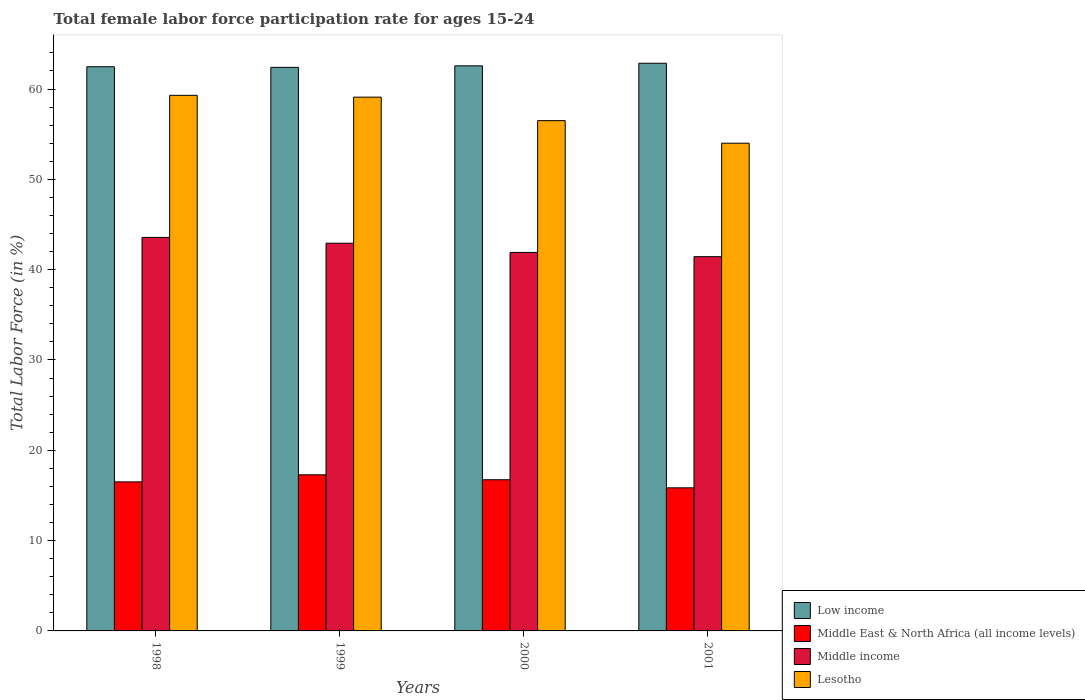How many different coloured bars are there?
Ensure brevity in your answer.  4. How many groups of bars are there?
Offer a very short reply. 4. Are the number of bars per tick equal to the number of legend labels?
Offer a terse response. Yes. Are the number of bars on each tick of the X-axis equal?
Ensure brevity in your answer.  Yes. What is the label of the 1st group of bars from the left?
Give a very brief answer. 1998. What is the female labor force participation rate in Middle income in 2001?
Provide a succinct answer. 41.44. Across all years, what is the maximum female labor force participation rate in Lesotho?
Ensure brevity in your answer.  59.3. Across all years, what is the minimum female labor force participation rate in Lesotho?
Ensure brevity in your answer.  54. In which year was the female labor force participation rate in Lesotho maximum?
Offer a very short reply. 1998. In which year was the female labor force participation rate in Middle income minimum?
Make the answer very short. 2001. What is the total female labor force participation rate in Middle East & North Africa (all income levels) in the graph?
Your answer should be compact. 66.37. What is the difference between the female labor force participation rate in Low income in 1999 and that in 2000?
Offer a very short reply. -0.17. What is the difference between the female labor force participation rate in Middle income in 2000 and the female labor force participation rate in Middle East & North Africa (all income levels) in 1999?
Keep it short and to the point. 24.62. What is the average female labor force participation rate in Middle income per year?
Offer a terse response. 42.46. In the year 1998, what is the difference between the female labor force participation rate in Lesotho and female labor force participation rate in Middle income?
Ensure brevity in your answer.  15.73. In how many years, is the female labor force participation rate in Middle East & North Africa (all income levels) greater than 18 %?
Your response must be concise. 0. What is the ratio of the female labor force participation rate in Lesotho in 1998 to that in 2000?
Keep it short and to the point. 1.05. Is the difference between the female labor force participation rate in Lesotho in 1998 and 1999 greater than the difference between the female labor force participation rate in Middle income in 1998 and 1999?
Offer a very short reply. No. What is the difference between the highest and the second highest female labor force participation rate in Middle East & North Africa (all income levels)?
Keep it short and to the point. 0.55. What is the difference between the highest and the lowest female labor force participation rate in Middle East & North Africa (all income levels)?
Offer a very short reply. 1.44. In how many years, is the female labor force participation rate in Lesotho greater than the average female labor force participation rate in Lesotho taken over all years?
Offer a very short reply. 2. Is the sum of the female labor force participation rate in Middle East & North Africa (all income levels) in 1998 and 2000 greater than the maximum female labor force participation rate in Lesotho across all years?
Your response must be concise. No. Is it the case that in every year, the sum of the female labor force participation rate in Lesotho and female labor force participation rate in Middle East & North Africa (all income levels) is greater than the sum of female labor force participation rate in Middle income and female labor force participation rate in Low income?
Your response must be concise. No. What does the 1st bar from the right in 1999 represents?
Your answer should be compact. Lesotho. Are all the bars in the graph horizontal?
Offer a terse response. No. What is the difference between two consecutive major ticks on the Y-axis?
Your answer should be compact. 10. Are the values on the major ticks of Y-axis written in scientific E-notation?
Your answer should be compact. No. How many legend labels are there?
Your answer should be compact. 4. What is the title of the graph?
Offer a terse response. Total female labor force participation rate for ages 15-24. What is the label or title of the Y-axis?
Keep it short and to the point. Total Labor Force (in %). What is the Total Labor Force (in %) of Low income in 1998?
Give a very brief answer. 62.47. What is the Total Labor Force (in %) of Middle East & North Africa (all income levels) in 1998?
Make the answer very short. 16.5. What is the Total Labor Force (in %) of Middle income in 1998?
Keep it short and to the point. 43.57. What is the Total Labor Force (in %) of Lesotho in 1998?
Offer a very short reply. 59.3. What is the Total Labor Force (in %) of Low income in 1999?
Give a very brief answer. 62.4. What is the Total Labor Force (in %) of Middle East & North Africa (all income levels) in 1999?
Your answer should be very brief. 17.28. What is the Total Labor Force (in %) of Middle income in 1999?
Ensure brevity in your answer.  42.93. What is the Total Labor Force (in %) of Lesotho in 1999?
Offer a very short reply. 59.1. What is the Total Labor Force (in %) in Low income in 2000?
Keep it short and to the point. 62.57. What is the Total Labor Force (in %) in Middle East & North Africa (all income levels) in 2000?
Give a very brief answer. 16.74. What is the Total Labor Force (in %) in Middle income in 2000?
Provide a succinct answer. 41.91. What is the Total Labor Force (in %) of Lesotho in 2000?
Provide a short and direct response. 56.5. What is the Total Labor Force (in %) of Low income in 2001?
Your answer should be very brief. 62.85. What is the Total Labor Force (in %) in Middle East & North Africa (all income levels) in 2001?
Your answer should be compact. 15.84. What is the Total Labor Force (in %) of Middle income in 2001?
Keep it short and to the point. 41.44. What is the Total Labor Force (in %) of Lesotho in 2001?
Ensure brevity in your answer.  54. Across all years, what is the maximum Total Labor Force (in %) in Low income?
Provide a succinct answer. 62.85. Across all years, what is the maximum Total Labor Force (in %) in Middle East & North Africa (all income levels)?
Your answer should be compact. 17.28. Across all years, what is the maximum Total Labor Force (in %) in Middle income?
Your response must be concise. 43.57. Across all years, what is the maximum Total Labor Force (in %) in Lesotho?
Your answer should be compact. 59.3. Across all years, what is the minimum Total Labor Force (in %) of Low income?
Your answer should be very brief. 62.4. Across all years, what is the minimum Total Labor Force (in %) in Middle East & North Africa (all income levels)?
Provide a succinct answer. 15.84. Across all years, what is the minimum Total Labor Force (in %) of Middle income?
Keep it short and to the point. 41.44. What is the total Total Labor Force (in %) of Low income in the graph?
Your answer should be very brief. 250.28. What is the total Total Labor Force (in %) of Middle East & North Africa (all income levels) in the graph?
Make the answer very short. 66.37. What is the total Total Labor Force (in %) of Middle income in the graph?
Ensure brevity in your answer.  169.84. What is the total Total Labor Force (in %) of Lesotho in the graph?
Your answer should be very brief. 228.9. What is the difference between the Total Labor Force (in %) in Low income in 1998 and that in 1999?
Make the answer very short. 0.07. What is the difference between the Total Labor Force (in %) of Middle East & North Africa (all income levels) in 1998 and that in 1999?
Keep it short and to the point. -0.78. What is the difference between the Total Labor Force (in %) in Middle income in 1998 and that in 1999?
Keep it short and to the point. 0.64. What is the difference between the Total Labor Force (in %) of Low income in 1998 and that in 2000?
Provide a short and direct response. -0.1. What is the difference between the Total Labor Force (in %) of Middle East & North Africa (all income levels) in 1998 and that in 2000?
Give a very brief answer. -0.24. What is the difference between the Total Labor Force (in %) in Middle income in 1998 and that in 2000?
Provide a short and direct response. 1.66. What is the difference between the Total Labor Force (in %) of Low income in 1998 and that in 2001?
Provide a short and direct response. -0.38. What is the difference between the Total Labor Force (in %) of Middle East & North Africa (all income levels) in 1998 and that in 2001?
Make the answer very short. 0.66. What is the difference between the Total Labor Force (in %) of Middle income in 1998 and that in 2001?
Provide a short and direct response. 2.13. What is the difference between the Total Labor Force (in %) in Low income in 1999 and that in 2000?
Your answer should be compact. -0.17. What is the difference between the Total Labor Force (in %) of Middle East & North Africa (all income levels) in 1999 and that in 2000?
Give a very brief answer. 0.55. What is the difference between the Total Labor Force (in %) in Middle income in 1999 and that in 2000?
Ensure brevity in your answer.  1.02. What is the difference between the Total Labor Force (in %) of Low income in 1999 and that in 2001?
Offer a terse response. -0.46. What is the difference between the Total Labor Force (in %) of Middle East & North Africa (all income levels) in 1999 and that in 2001?
Ensure brevity in your answer.  1.44. What is the difference between the Total Labor Force (in %) in Middle income in 1999 and that in 2001?
Offer a terse response. 1.49. What is the difference between the Total Labor Force (in %) in Lesotho in 1999 and that in 2001?
Make the answer very short. 5.1. What is the difference between the Total Labor Force (in %) in Low income in 2000 and that in 2001?
Make the answer very short. -0.29. What is the difference between the Total Labor Force (in %) in Middle East & North Africa (all income levels) in 2000 and that in 2001?
Keep it short and to the point. 0.9. What is the difference between the Total Labor Force (in %) in Middle income in 2000 and that in 2001?
Keep it short and to the point. 0.47. What is the difference between the Total Labor Force (in %) of Low income in 1998 and the Total Labor Force (in %) of Middle East & North Africa (all income levels) in 1999?
Ensure brevity in your answer.  45.18. What is the difference between the Total Labor Force (in %) of Low income in 1998 and the Total Labor Force (in %) of Middle income in 1999?
Your answer should be compact. 19.54. What is the difference between the Total Labor Force (in %) of Low income in 1998 and the Total Labor Force (in %) of Lesotho in 1999?
Offer a very short reply. 3.37. What is the difference between the Total Labor Force (in %) of Middle East & North Africa (all income levels) in 1998 and the Total Labor Force (in %) of Middle income in 1999?
Your response must be concise. -26.43. What is the difference between the Total Labor Force (in %) of Middle East & North Africa (all income levels) in 1998 and the Total Labor Force (in %) of Lesotho in 1999?
Ensure brevity in your answer.  -42.6. What is the difference between the Total Labor Force (in %) of Middle income in 1998 and the Total Labor Force (in %) of Lesotho in 1999?
Provide a succinct answer. -15.53. What is the difference between the Total Labor Force (in %) of Low income in 1998 and the Total Labor Force (in %) of Middle East & North Africa (all income levels) in 2000?
Offer a very short reply. 45.73. What is the difference between the Total Labor Force (in %) in Low income in 1998 and the Total Labor Force (in %) in Middle income in 2000?
Your answer should be very brief. 20.56. What is the difference between the Total Labor Force (in %) of Low income in 1998 and the Total Labor Force (in %) of Lesotho in 2000?
Provide a short and direct response. 5.97. What is the difference between the Total Labor Force (in %) of Middle East & North Africa (all income levels) in 1998 and the Total Labor Force (in %) of Middle income in 2000?
Your answer should be very brief. -25.41. What is the difference between the Total Labor Force (in %) in Middle East & North Africa (all income levels) in 1998 and the Total Labor Force (in %) in Lesotho in 2000?
Your answer should be compact. -40. What is the difference between the Total Labor Force (in %) in Middle income in 1998 and the Total Labor Force (in %) in Lesotho in 2000?
Keep it short and to the point. -12.93. What is the difference between the Total Labor Force (in %) in Low income in 1998 and the Total Labor Force (in %) in Middle East & North Africa (all income levels) in 2001?
Keep it short and to the point. 46.63. What is the difference between the Total Labor Force (in %) in Low income in 1998 and the Total Labor Force (in %) in Middle income in 2001?
Your answer should be very brief. 21.03. What is the difference between the Total Labor Force (in %) in Low income in 1998 and the Total Labor Force (in %) in Lesotho in 2001?
Provide a succinct answer. 8.47. What is the difference between the Total Labor Force (in %) of Middle East & North Africa (all income levels) in 1998 and the Total Labor Force (in %) of Middle income in 2001?
Offer a very short reply. -24.94. What is the difference between the Total Labor Force (in %) of Middle East & North Africa (all income levels) in 1998 and the Total Labor Force (in %) of Lesotho in 2001?
Provide a succinct answer. -37.5. What is the difference between the Total Labor Force (in %) in Middle income in 1998 and the Total Labor Force (in %) in Lesotho in 2001?
Your answer should be very brief. -10.43. What is the difference between the Total Labor Force (in %) in Low income in 1999 and the Total Labor Force (in %) in Middle East & North Africa (all income levels) in 2000?
Offer a very short reply. 45.66. What is the difference between the Total Labor Force (in %) in Low income in 1999 and the Total Labor Force (in %) in Middle income in 2000?
Offer a terse response. 20.49. What is the difference between the Total Labor Force (in %) of Low income in 1999 and the Total Labor Force (in %) of Lesotho in 2000?
Keep it short and to the point. 5.9. What is the difference between the Total Labor Force (in %) in Middle East & North Africa (all income levels) in 1999 and the Total Labor Force (in %) in Middle income in 2000?
Offer a very short reply. -24.62. What is the difference between the Total Labor Force (in %) in Middle East & North Africa (all income levels) in 1999 and the Total Labor Force (in %) in Lesotho in 2000?
Give a very brief answer. -39.22. What is the difference between the Total Labor Force (in %) of Middle income in 1999 and the Total Labor Force (in %) of Lesotho in 2000?
Offer a very short reply. -13.57. What is the difference between the Total Labor Force (in %) in Low income in 1999 and the Total Labor Force (in %) in Middle East & North Africa (all income levels) in 2001?
Offer a terse response. 46.55. What is the difference between the Total Labor Force (in %) of Low income in 1999 and the Total Labor Force (in %) of Middle income in 2001?
Offer a very short reply. 20.96. What is the difference between the Total Labor Force (in %) of Low income in 1999 and the Total Labor Force (in %) of Lesotho in 2001?
Your response must be concise. 8.4. What is the difference between the Total Labor Force (in %) of Middle East & North Africa (all income levels) in 1999 and the Total Labor Force (in %) of Middle income in 2001?
Your answer should be compact. -24.15. What is the difference between the Total Labor Force (in %) of Middle East & North Africa (all income levels) in 1999 and the Total Labor Force (in %) of Lesotho in 2001?
Provide a short and direct response. -36.72. What is the difference between the Total Labor Force (in %) of Middle income in 1999 and the Total Labor Force (in %) of Lesotho in 2001?
Provide a short and direct response. -11.07. What is the difference between the Total Labor Force (in %) of Low income in 2000 and the Total Labor Force (in %) of Middle East & North Africa (all income levels) in 2001?
Your answer should be compact. 46.72. What is the difference between the Total Labor Force (in %) in Low income in 2000 and the Total Labor Force (in %) in Middle income in 2001?
Make the answer very short. 21.13. What is the difference between the Total Labor Force (in %) of Low income in 2000 and the Total Labor Force (in %) of Lesotho in 2001?
Your answer should be compact. 8.57. What is the difference between the Total Labor Force (in %) in Middle East & North Africa (all income levels) in 2000 and the Total Labor Force (in %) in Middle income in 2001?
Give a very brief answer. -24.7. What is the difference between the Total Labor Force (in %) of Middle East & North Africa (all income levels) in 2000 and the Total Labor Force (in %) of Lesotho in 2001?
Your answer should be very brief. -37.26. What is the difference between the Total Labor Force (in %) in Middle income in 2000 and the Total Labor Force (in %) in Lesotho in 2001?
Your answer should be compact. -12.09. What is the average Total Labor Force (in %) of Low income per year?
Your answer should be very brief. 62.57. What is the average Total Labor Force (in %) of Middle East & North Africa (all income levels) per year?
Make the answer very short. 16.59. What is the average Total Labor Force (in %) of Middle income per year?
Make the answer very short. 42.46. What is the average Total Labor Force (in %) of Lesotho per year?
Keep it short and to the point. 57.23. In the year 1998, what is the difference between the Total Labor Force (in %) of Low income and Total Labor Force (in %) of Middle East & North Africa (all income levels)?
Your answer should be very brief. 45.97. In the year 1998, what is the difference between the Total Labor Force (in %) of Low income and Total Labor Force (in %) of Middle income?
Make the answer very short. 18.9. In the year 1998, what is the difference between the Total Labor Force (in %) in Low income and Total Labor Force (in %) in Lesotho?
Ensure brevity in your answer.  3.17. In the year 1998, what is the difference between the Total Labor Force (in %) in Middle East & North Africa (all income levels) and Total Labor Force (in %) in Middle income?
Ensure brevity in your answer.  -27.07. In the year 1998, what is the difference between the Total Labor Force (in %) in Middle East & North Africa (all income levels) and Total Labor Force (in %) in Lesotho?
Make the answer very short. -42.8. In the year 1998, what is the difference between the Total Labor Force (in %) in Middle income and Total Labor Force (in %) in Lesotho?
Provide a succinct answer. -15.73. In the year 1999, what is the difference between the Total Labor Force (in %) in Low income and Total Labor Force (in %) in Middle East & North Africa (all income levels)?
Keep it short and to the point. 45.11. In the year 1999, what is the difference between the Total Labor Force (in %) in Low income and Total Labor Force (in %) in Middle income?
Ensure brevity in your answer.  19.47. In the year 1999, what is the difference between the Total Labor Force (in %) in Low income and Total Labor Force (in %) in Lesotho?
Ensure brevity in your answer.  3.3. In the year 1999, what is the difference between the Total Labor Force (in %) in Middle East & North Africa (all income levels) and Total Labor Force (in %) in Middle income?
Provide a succinct answer. -25.64. In the year 1999, what is the difference between the Total Labor Force (in %) of Middle East & North Africa (all income levels) and Total Labor Force (in %) of Lesotho?
Offer a very short reply. -41.82. In the year 1999, what is the difference between the Total Labor Force (in %) of Middle income and Total Labor Force (in %) of Lesotho?
Offer a very short reply. -16.17. In the year 2000, what is the difference between the Total Labor Force (in %) in Low income and Total Labor Force (in %) in Middle East & North Africa (all income levels)?
Your answer should be very brief. 45.83. In the year 2000, what is the difference between the Total Labor Force (in %) in Low income and Total Labor Force (in %) in Middle income?
Ensure brevity in your answer.  20.66. In the year 2000, what is the difference between the Total Labor Force (in %) of Low income and Total Labor Force (in %) of Lesotho?
Your answer should be compact. 6.07. In the year 2000, what is the difference between the Total Labor Force (in %) of Middle East & North Africa (all income levels) and Total Labor Force (in %) of Middle income?
Give a very brief answer. -25.17. In the year 2000, what is the difference between the Total Labor Force (in %) of Middle East & North Africa (all income levels) and Total Labor Force (in %) of Lesotho?
Offer a very short reply. -39.76. In the year 2000, what is the difference between the Total Labor Force (in %) in Middle income and Total Labor Force (in %) in Lesotho?
Provide a succinct answer. -14.59. In the year 2001, what is the difference between the Total Labor Force (in %) in Low income and Total Labor Force (in %) in Middle East & North Africa (all income levels)?
Your answer should be compact. 47.01. In the year 2001, what is the difference between the Total Labor Force (in %) of Low income and Total Labor Force (in %) of Middle income?
Give a very brief answer. 21.42. In the year 2001, what is the difference between the Total Labor Force (in %) of Low income and Total Labor Force (in %) of Lesotho?
Your response must be concise. 8.85. In the year 2001, what is the difference between the Total Labor Force (in %) of Middle East & North Africa (all income levels) and Total Labor Force (in %) of Middle income?
Ensure brevity in your answer.  -25.59. In the year 2001, what is the difference between the Total Labor Force (in %) in Middle East & North Africa (all income levels) and Total Labor Force (in %) in Lesotho?
Offer a terse response. -38.16. In the year 2001, what is the difference between the Total Labor Force (in %) in Middle income and Total Labor Force (in %) in Lesotho?
Make the answer very short. -12.56. What is the ratio of the Total Labor Force (in %) in Middle East & North Africa (all income levels) in 1998 to that in 1999?
Your answer should be very brief. 0.95. What is the ratio of the Total Labor Force (in %) in Middle East & North Africa (all income levels) in 1998 to that in 2000?
Make the answer very short. 0.99. What is the ratio of the Total Labor Force (in %) in Middle income in 1998 to that in 2000?
Provide a succinct answer. 1.04. What is the ratio of the Total Labor Force (in %) in Lesotho in 1998 to that in 2000?
Your answer should be very brief. 1.05. What is the ratio of the Total Labor Force (in %) of Low income in 1998 to that in 2001?
Your answer should be very brief. 0.99. What is the ratio of the Total Labor Force (in %) of Middle East & North Africa (all income levels) in 1998 to that in 2001?
Give a very brief answer. 1.04. What is the ratio of the Total Labor Force (in %) of Middle income in 1998 to that in 2001?
Give a very brief answer. 1.05. What is the ratio of the Total Labor Force (in %) in Lesotho in 1998 to that in 2001?
Give a very brief answer. 1.1. What is the ratio of the Total Labor Force (in %) in Low income in 1999 to that in 2000?
Your answer should be very brief. 1. What is the ratio of the Total Labor Force (in %) of Middle East & North Africa (all income levels) in 1999 to that in 2000?
Provide a short and direct response. 1.03. What is the ratio of the Total Labor Force (in %) of Middle income in 1999 to that in 2000?
Your answer should be very brief. 1.02. What is the ratio of the Total Labor Force (in %) of Lesotho in 1999 to that in 2000?
Ensure brevity in your answer.  1.05. What is the ratio of the Total Labor Force (in %) of Low income in 1999 to that in 2001?
Your response must be concise. 0.99. What is the ratio of the Total Labor Force (in %) of Middle East & North Africa (all income levels) in 1999 to that in 2001?
Provide a short and direct response. 1.09. What is the ratio of the Total Labor Force (in %) in Middle income in 1999 to that in 2001?
Keep it short and to the point. 1.04. What is the ratio of the Total Labor Force (in %) of Lesotho in 1999 to that in 2001?
Ensure brevity in your answer.  1.09. What is the ratio of the Total Labor Force (in %) in Middle East & North Africa (all income levels) in 2000 to that in 2001?
Make the answer very short. 1.06. What is the ratio of the Total Labor Force (in %) in Middle income in 2000 to that in 2001?
Offer a very short reply. 1.01. What is the ratio of the Total Labor Force (in %) of Lesotho in 2000 to that in 2001?
Your answer should be very brief. 1.05. What is the difference between the highest and the second highest Total Labor Force (in %) in Low income?
Give a very brief answer. 0.29. What is the difference between the highest and the second highest Total Labor Force (in %) in Middle East & North Africa (all income levels)?
Provide a succinct answer. 0.55. What is the difference between the highest and the second highest Total Labor Force (in %) of Middle income?
Your response must be concise. 0.64. What is the difference between the highest and the second highest Total Labor Force (in %) in Lesotho?
Make the answer very short. 0.2. What is the difference between the highest and the lowest Total Labor Force (in %) of Low income?
Offer a terse response. 0.46. What is the difference between the highest and the lowest Total Labor Force (in %) of Middle East & North Africa (all income levels)?
Keep it short and to the point. 1.44. What is the difference between the highest and the lowest Total Labor Force (in %) of Middle income?
Offer a very short reply. 2.13. 